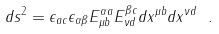Convert formula to latex. <formula><loc_0><loc_0><loc_500><loc_500>d s ^ { 2 } = \epsilon _ { a c } \epsilon _ { \alpha \beta } E ^ { \alpha a } _ { \mu b } E ^ { \beta c } _ { \nu d } d x ^ { \mu b } d x ^ { \nu d } \ .</formula> 